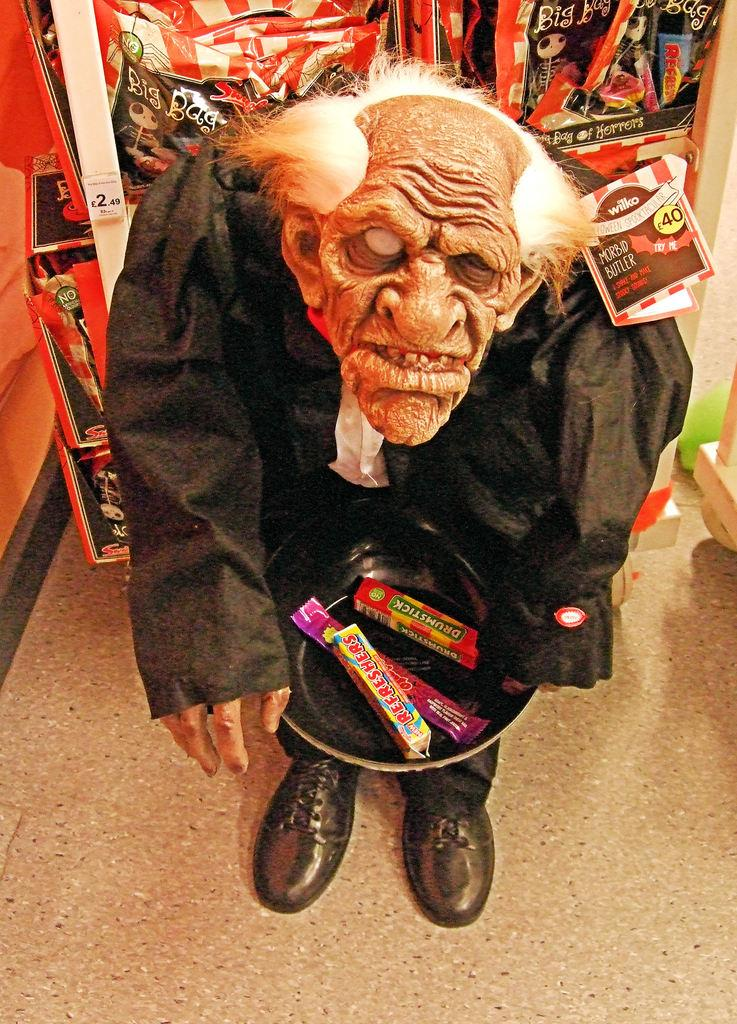What is the main subject of the image? There is a toy person in the image. What is the toy person holding? The toy person is holding a plate of items. Can you describe the background of the image? There are objects in the background of the image. What type of kite is the toy person flying in the image? There is no kite present in the image; the toy person is holding a plate of items. 